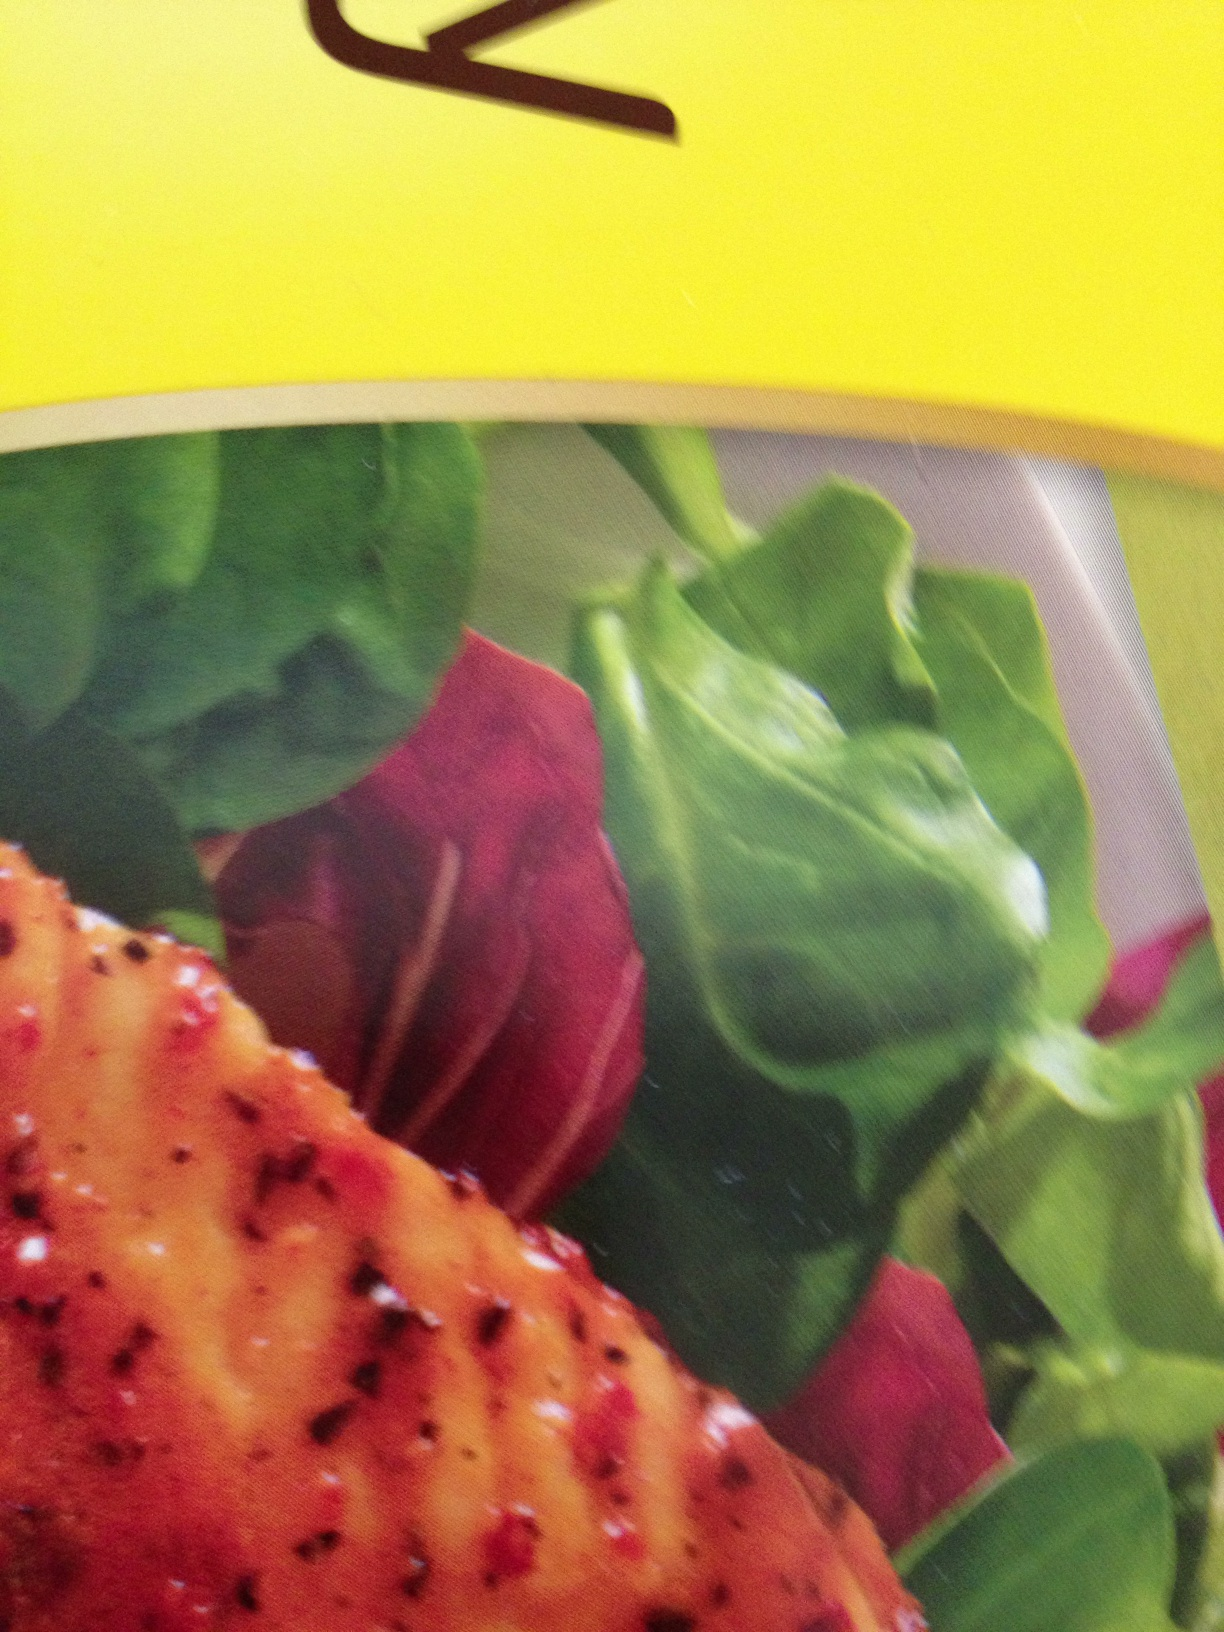Imagine what's happening right before this dish was photographed. What do you see? Right before this dish was photographed, I see a bustling kitchen with a chef meticulously arranging the elements on the plate. The meat is freshly grilled, still steaming slightly as it's placed carefully atop the vibrant greens. The beet slices are added with precision, creating a visually appealing color contrast. The chef steps back for a moment, checks the composition, perhaps adds a touch of garnish or a drop of dressing, and finally signals the photographer to capture the carefully orchestrated culinary masterpiece. 